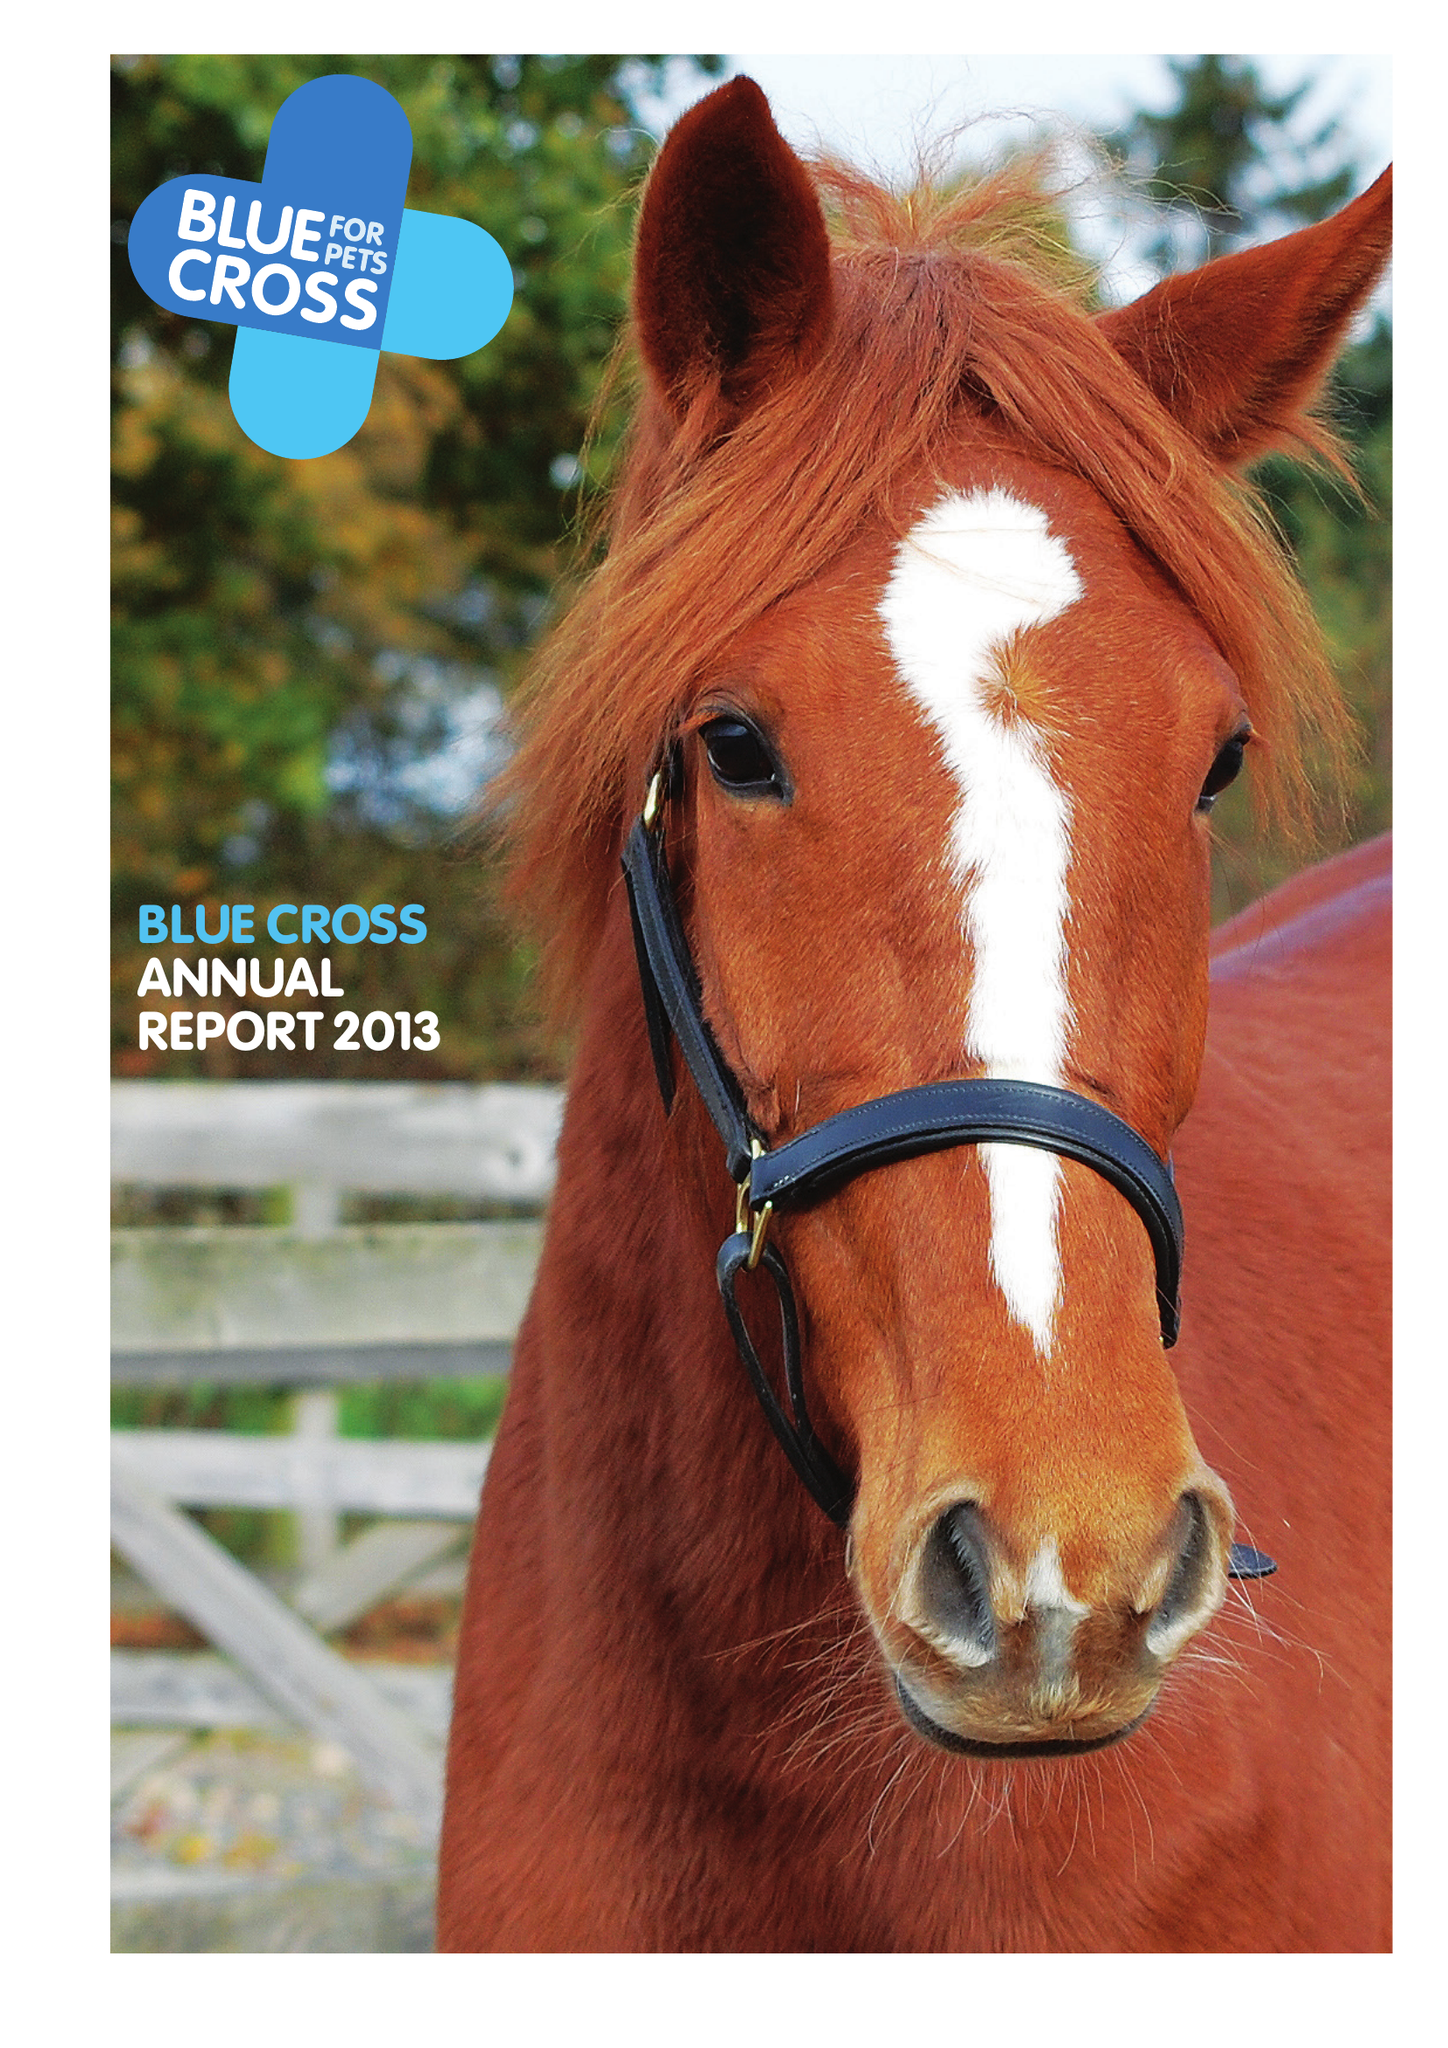What is the value for the charity_name?
Answer the question using a single word or phrase. Blue Cross 